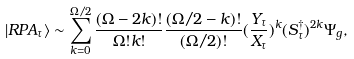Convert formula to latex. <formula><loc_0><loc_0><loc_500><loc_500>| R P A _ { \tau } \rangle \sim \sum _ { k = 0 } ^ { \Omega / 2 } \frac { ( \Omega - 2 k ) ! } { \Omega ! k ! } \frac { ( \Omega / 2 - k ) ! } { ( \Omega / 2 ) ! } ( \frac { Y _ { \tau } } { X _ { \tau } } ) ^ { k } ( S _ { \tau } ^ { \dagger } ) ^ { 2 k } \Psi _ { g } ,</formula> 